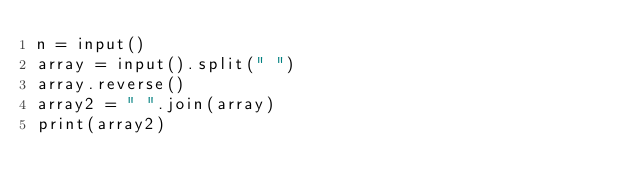<code> <loc_0><loc_0><loc_500><loc_500><_Python_>n = input()
array = input().split(" ")
array.reverse()
array2 = " ".join(array)
print(array2)
</code> 